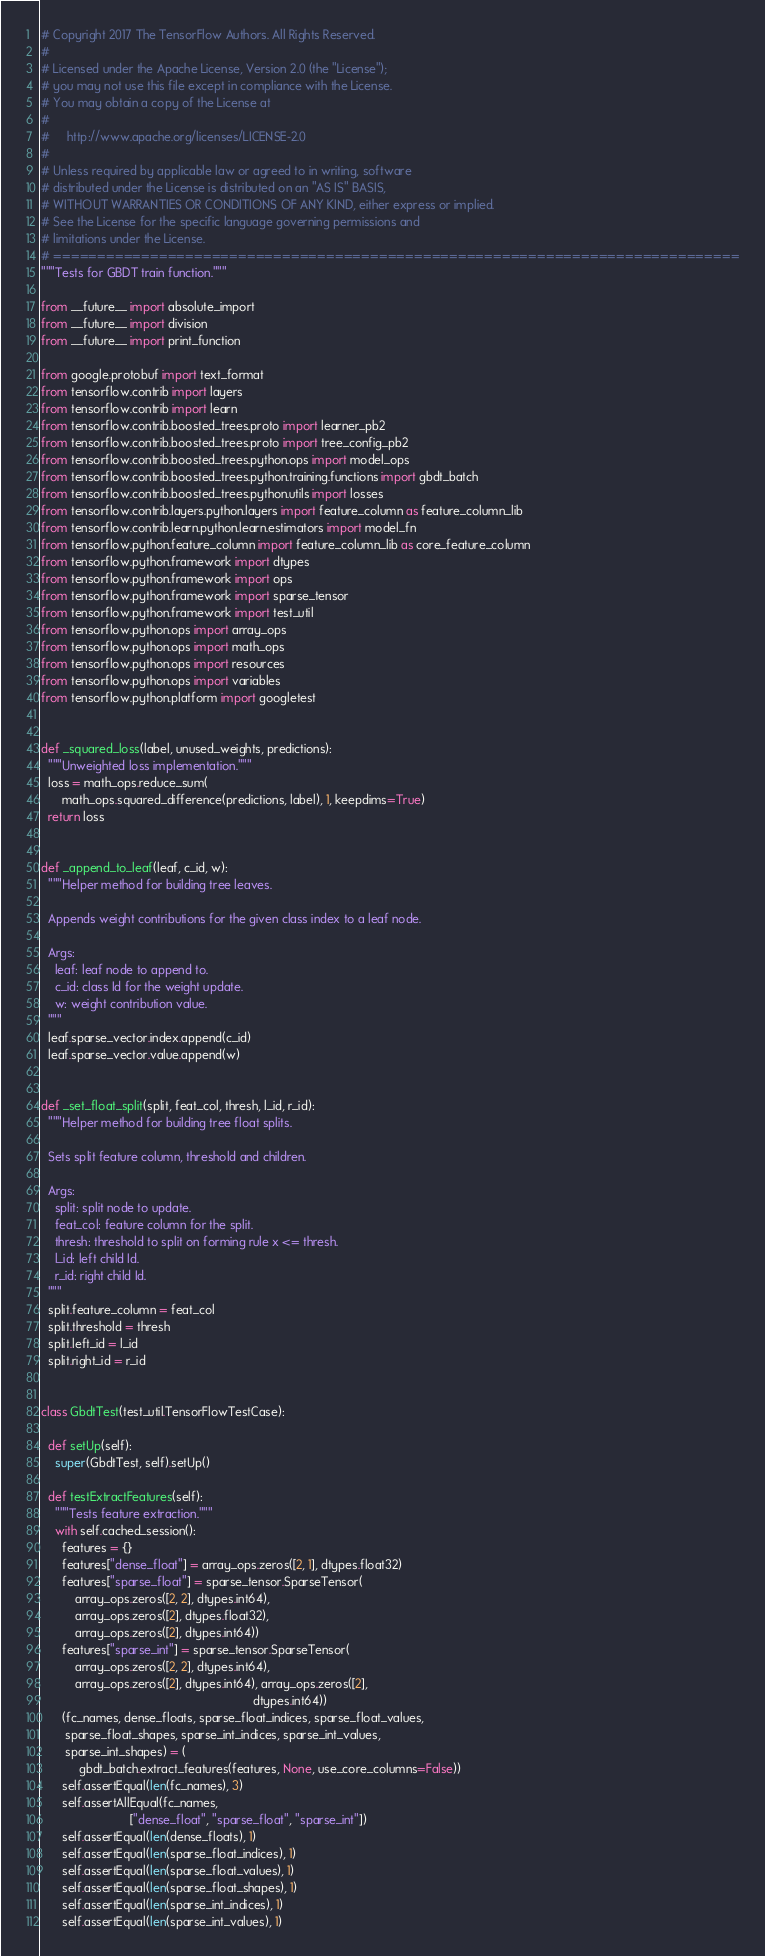<code> <loc_0><loc_0><loc_500><loc_500><_Python_># Copyright 2017 The TensorFlow Authors. All Rights Reserved.
#
# Licensed under the Apache License, Version 2.0 (the "License");
# you may not use this file except in compliance with the License.
# You may obtain a copy of the License at
#
#     http://www.apache.org/licenses/LICENSE-2.0
#
# Unless required by applicable law or agreed to in writing, software
# distributed under the License is distributed on an "AS IS" BASIS,
# WITHOUT WARRANTIES OR CONDITIONS OF ANY KIND, either express or implied.
# See the License for the specific language governing permissions and
# limitations under the License.
# ==============================================================================
"""Tests for GBDT train function."""

from __future__ import absolute_import
from __future__ import division
from __future__ import print_function

from google.protobuf import text_format
from tensorflow.contrib import layers
from tensorflow.contrib import learn
from tensorflow.contrib.boosted_trees.proto import learner_pb2
from tensorflow.contrib.boosted_trees.proto import tree_config_pb2
from tensorflow.contrib.boosted_trees.python.ops import model_ops
from tensorflow.contrib.boosted_trees.python.training.functions import gbdt_batch
from tensorflow.contrib.boosted_trees.python.utils import losses
from tensorflow.contrib.layers.python.layers import feature_column as feature_column_lib
from tensorflow.contrib.learn.python.learn.estimators import model_fn
from tensorflow.python.feature_column import feature_column_lib as core_feature_column
from tensorflow.python.framework import dtypes
from tensorflow.python.framework import ops
from tensorflow.python.framework import sparse_tensor
from tensorflow.python.framework import test_util
from tensorflow.python.ops import array_ops
from tensorflow.python.ops import math_ops
from tensorflow.python.ops import resources
from tensorflow.python.ops import variables
from tensorflow.python.platform import googletest


def _squared_loss(label, unused_weights, predictions):
  """Unweighted loss implementation."""
  loss = math_ops.reduce_sum(
      math_ops.squared_difference(predictions, label), 1, keepdims=True)
  return loss


def _append_to_leaf(leaf, c_id, w):
  """Helper method for building tree leaves.

  Appends weight contributions for the given class index to a leaf node.

  Args:
    leaf: leaf node to append to.
    c_id: class Id for the weight update.
    w: weight contribution value.
  """
  leaf.sparse_vector.index.append(c_id)
  leaf.sparse_vector.value.append(w)


def _set_float_split(split, feat_col, thresh, l_id, r_id):
  """Helper method for building tree float splits.

  Sets split feature column, threshold and children.

  Args:
    split: split node to update.
    feat_col: feature column for the split.
    thresh: threshold to split on forming rule x <= thresh.
    l_id: left child Id.
    r_id: right child Id.
  """
  split.feature_column = feat_col
  split.threshold = thresh
  split.left_id = l_id
  split.right_id = r_id


class GbdtTest(test_util.TensorFlowTestCase):

  def setUp(self):
    super(GbdtTest, self).setUp()

  def testExtractFeatures(self):
    """Tests feature extraction."""
    with self.cached_session():
      features = {}
      features["dense_float"] = array_ops.zeros([2, 1], dtypes.float32)
      features["sparse_float"] = sparse_tensor.SparseTensor(
          array_ops.zeros([2, 2], dtypes.int64),
          array_ops.zeros([2], dtypes.float32),
          array_ops.zeros([2], dtypes.int64))
      features["sparse_int"] = sparse_tensor.SparseTensor(
          array_ops.zeros([2, 2], dtypes.int64),
          array_ops.zeros([2], dtypes.int64), array_ops.zeros([2],
                                                              dtypes.int64))
      (fc_names, dense_floats, sparse_float_indices, sparse_float_values,
       sparse_float_shapes, sparse_int_indices, sparse_int_values,
       sparse_int_shapes) = (
           gbdt_batch.extract_features(features, None, use_core_columns=False))
      self.assertEqual(len(fc_names), 3)
      self.assertAllEqual(fc_names,
                          ["dense_float", "sparse_float", "sparse_int"])
      self.assertEqual(len(dense_floats), 1)
      self.assertEqual(len(sparse_float_indices), 1)
      self.assertEqual(len(sparse_float_values), 1)
      self.assertEqual(len(sparse_float_shapes), 1)
      self.assertEqual(len(sparse_int_indices), 1)
      self.assertEqual(len(sparse_int_values), 1)</code> 